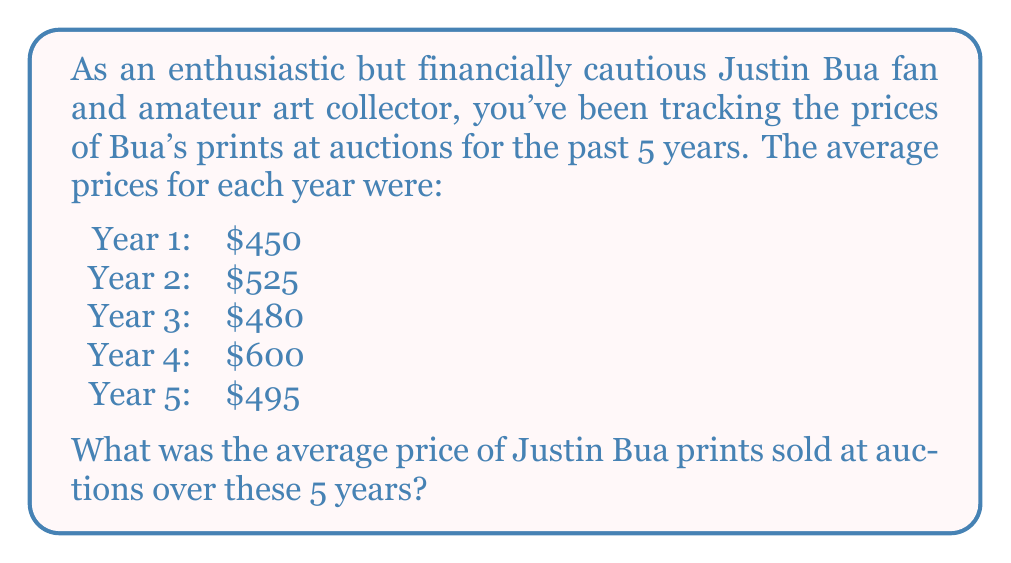Teach me how to tackle this problem. To find the average price of Justin Bua prints sold at auctions over the 5-year period, we need to:

1. Add up the average prices from each year
2. Divide the sum by the number of years

Let's break it down step-by-step:

1. Sum of average prices:
   $$450 + 525 + 480 + 600 + 495 = 2550$$

2. Number of years: 5

3. Calculate the average:
   $$\text{Average} = \frac{\text{Sum of values}}{\text{Number of values}}$$
   $$\text{Average} = \frac{2550}{5} = 510$$

Therefore, the average price of Justin Bua prints sold at auctions over these 5 years is $510.
Answer: $510 